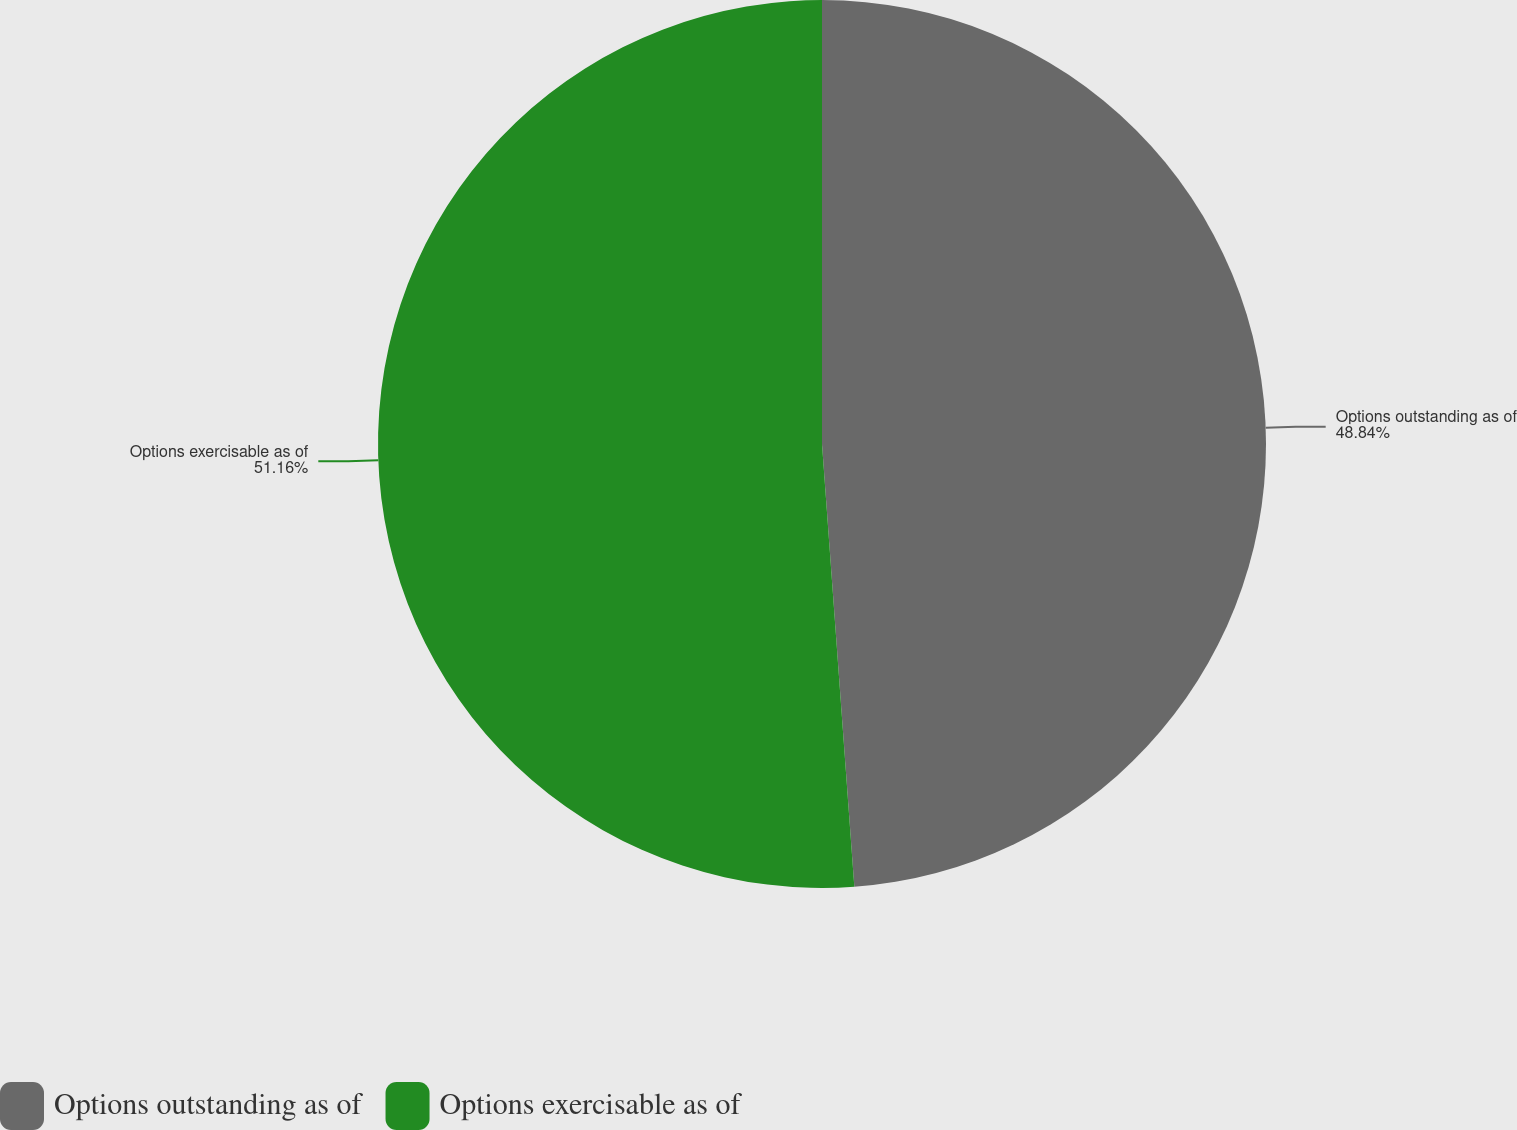<chart> <loc_0><loc_0><loc_500><loc_500><pie_chart><fcel>Options outstanding as of<fcel>Options exercisable as of<nl><fcel>48.84%<fcel>51.16%<nl></chart> 